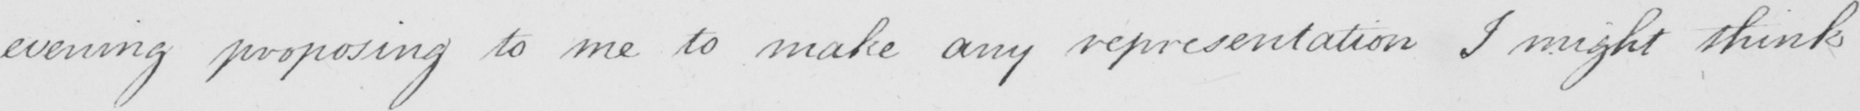What does this handwritten line say? evening proposing to me to make any representations I might think 